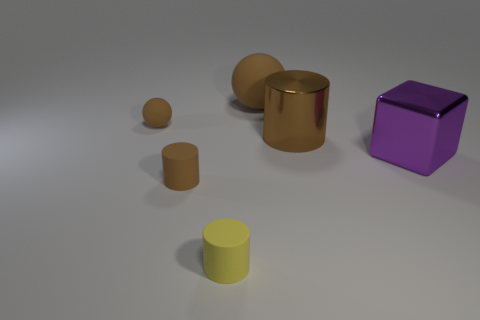Subtract all rubber cylinders. How many cylinders are left? 1 Subtract all blue spheres. How many brown cylinders are left? 2 Add 1 large purple shiny things. How many objects exist? 7 Subtract all blocks. How many objects are left? 5 Subtract 0 green cylinders. How many objects are left? 6 Subtract all large rubber objects. Subtract all small purple rubber balls. How many objects are left? 5 Add 6 large brown cylinders. How many large brown cylinders are left? 7 Add 2 large red metal blocks. How many large red metal blocks exist? 2 